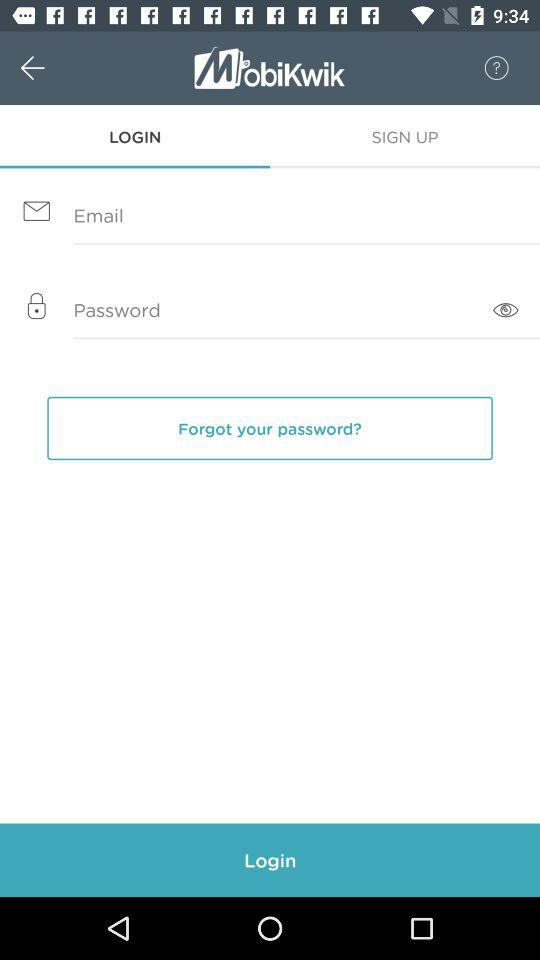What is the name of the application? The name of the application is "MobiKwik". 